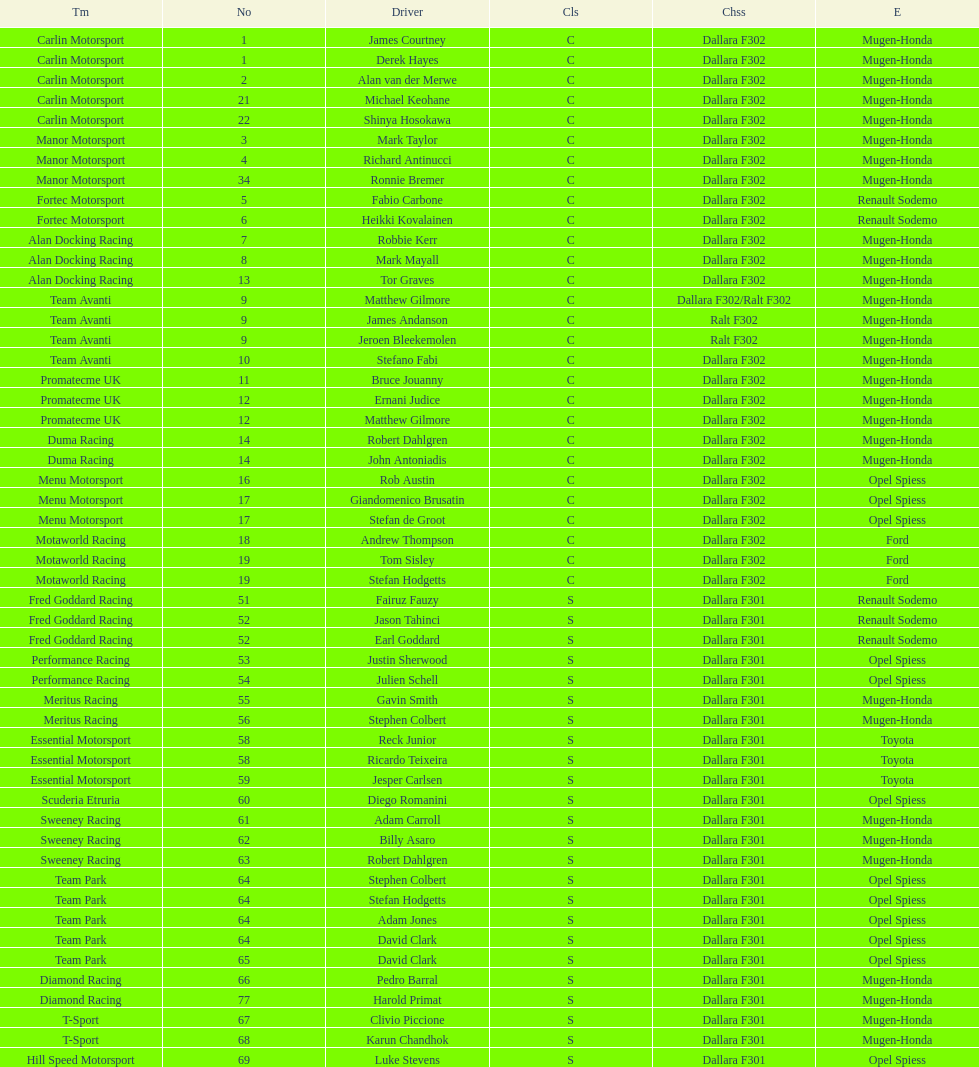What team is listed above diamond racing? Team Park. 